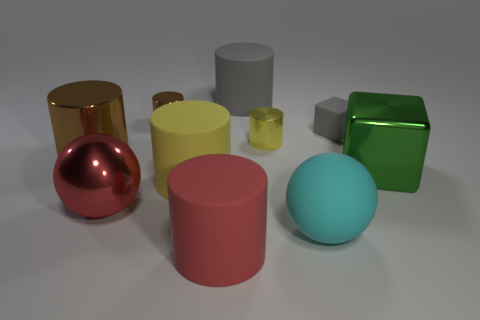How many things are big blocks behind the big red rubber thing or red rubber cylinders?
Keep it short and to the point. 2. Are there fewer tiny yellow metallic cylinders on the left side of the large cyan sphere than big matte cylinders on the right side of the large green metal block?
Provide a short and direct response. No. What number of other things are there of the same size as the shiny cube?
Ensure brevity in your answer.  6. Is the cyan thing made of the same material as the gray object that is on the left side of the cyan rubber sphere?
Keep it short and to the point. Yes. What number of objects are blocks that are behind the green thing or things behind the cyan rubber sphere?
Your answer should be compact. 8. The matte cube is what color?
Offer a terse response. Gray. Are there fewer red cylinders behind the gray cylinder than large cubes?
Your answer should be compact. Yes. Is there anything else that is the same shape as the large yellow rubber thing?
Your answer should be very brief. Yes. Is there a yellow matte ball?
Ensure brevity in your answer.  No. Are there fewer green metal cylinders than rubber objects?
Your response must be concise. Yes. 